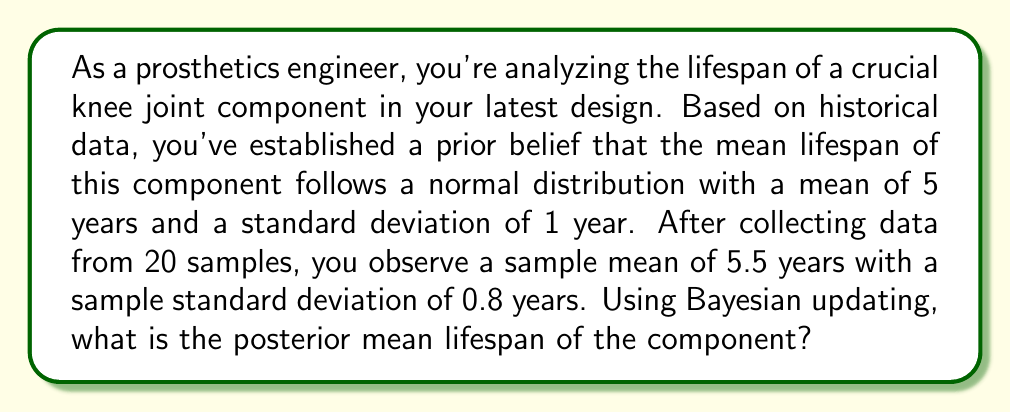Can you answer this question? To solve this problem, we'll use Bayesian updating for normal distributions with known variance. The steps are as follows:

1) First, let's define our variables:
   $\mu_0$ = prior mean = 5 years
   $\sigma_0$ = prior standard deviation = 1 year
   $\bar{x}$ = sample mean = 5.5 years
   $s$ = sample standard deviation = 0.8 years
   $n$ = sample size = 20

2) We need to calculate the posterior mean using the formula:

   $$\mu_1 = \frac{\frac{\mu_0}{\sigma_0^2} + \frac{n\bar{x}}{s^2}}{\frac{1}{\sigma_0^2} + \frac{n}{s^2}}$$

3) Let's substitute our values:

   $$\mu_1 = \frac{\frac{5}{1^2} + \frac{20 \cdot 5.5}{0.8^2}}{\frac{1}{1^2} + \frac{20}{0.8^2}}$$

4) Simplify:
   
   $$\mu_1 = \frac{5 + \frac{110}{0.64}}{1 + \frac{20}{0.64}}$$

5) Calculate:
   
   $$\mu_1 = \frac{5 + 171.875}{1 + 31.25} = \frac{176.875}{32.25} \approx 5.484$$

Therefore, the posterior mean lifespan of the component is approximately 5.484 years.
Answer: 5.484 years 